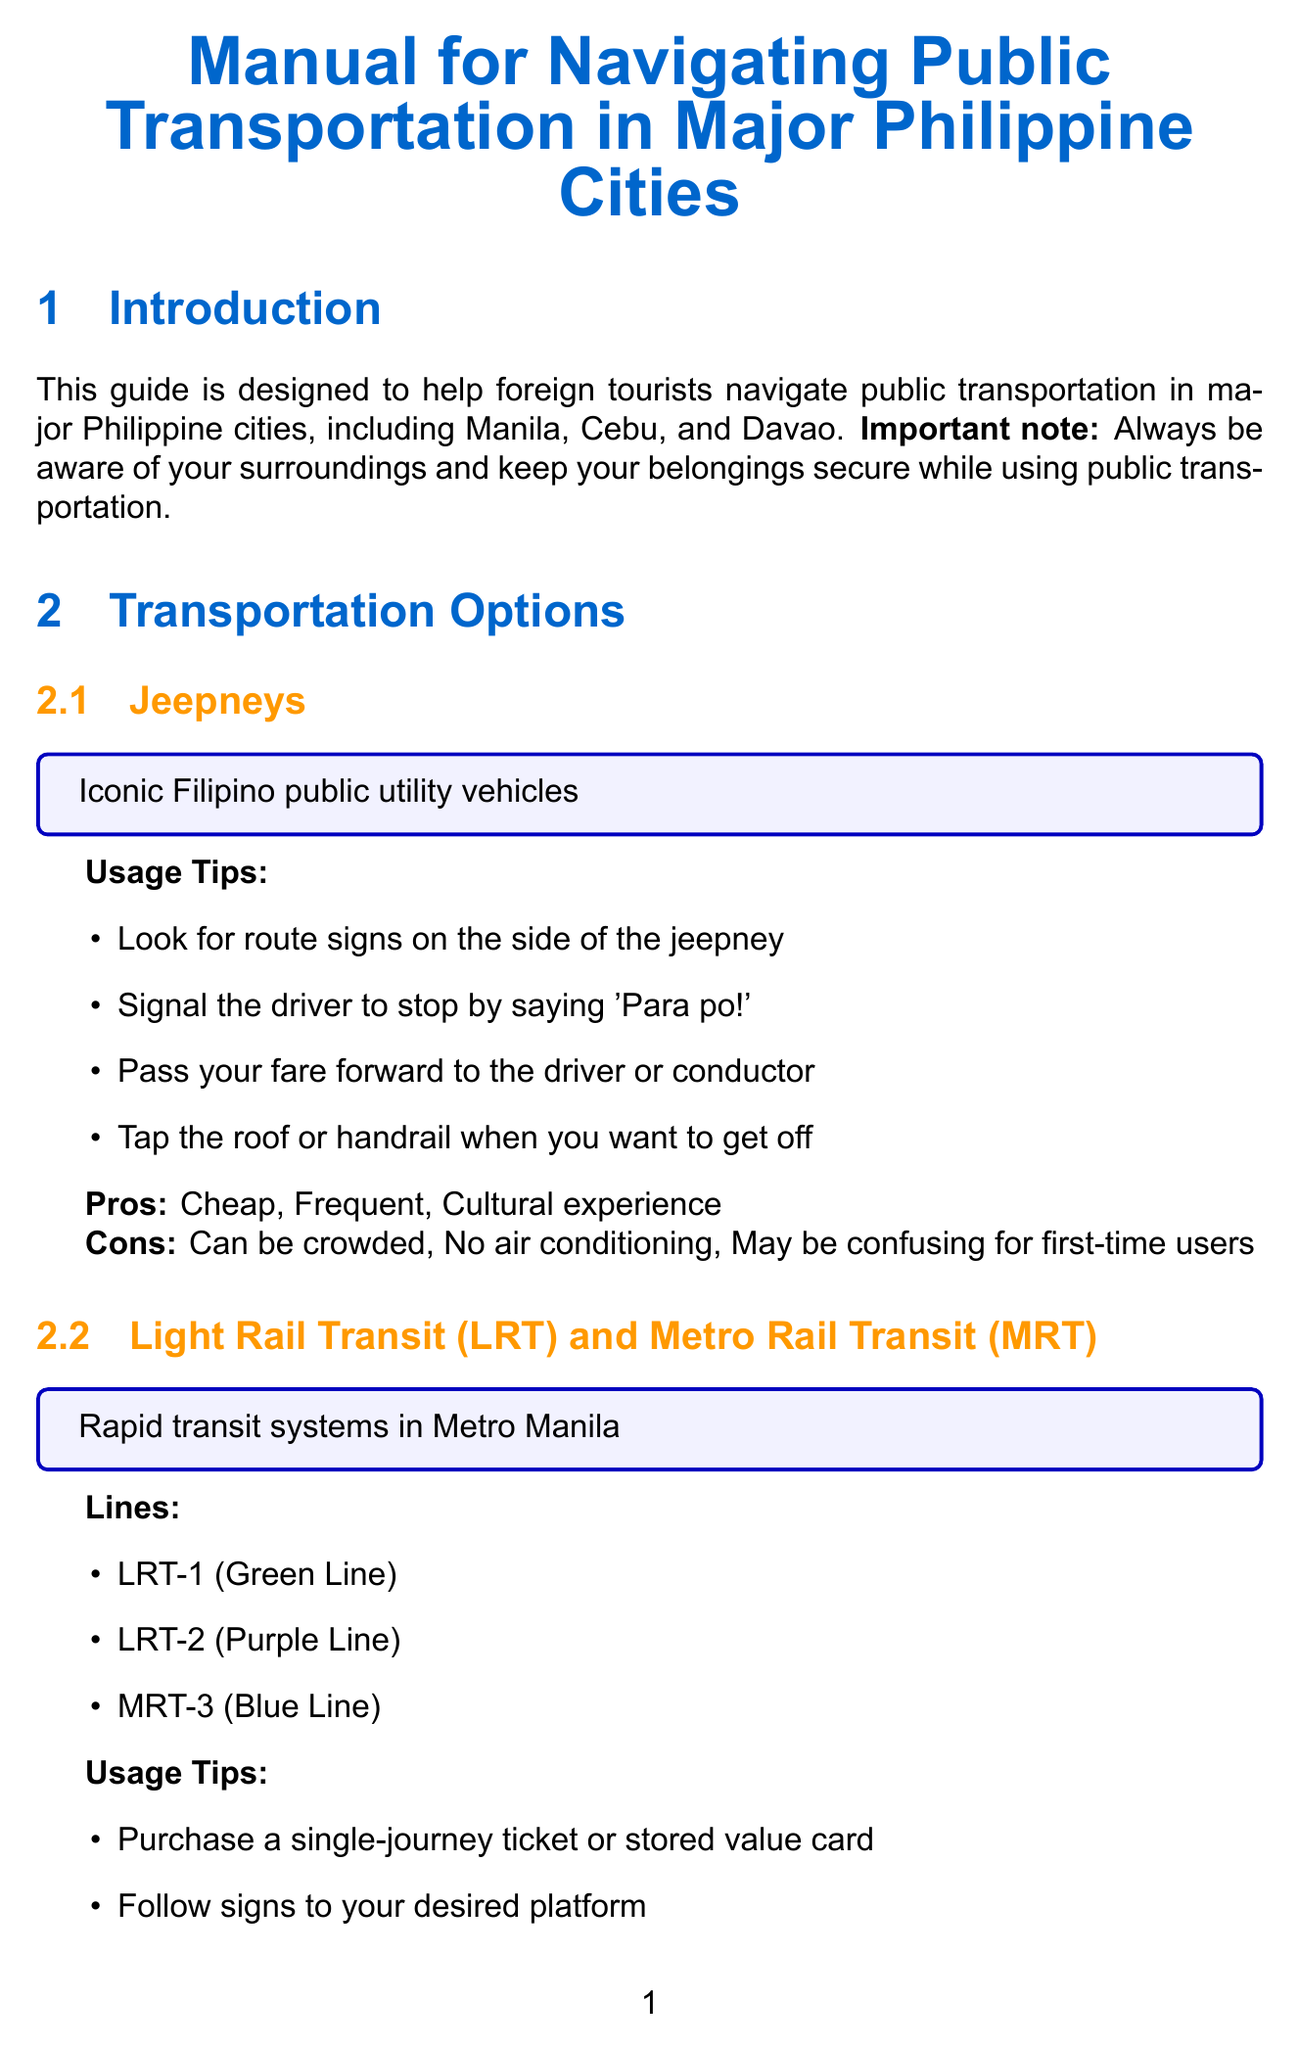What is the main purpose of this manual? The manual is designed to help foreign tourists navigate public transportation in major Philippine cities.
Answer: Help foreign tourists navigate public transportation How many rapid transit lines are mentioned? The document lists three rapid transit lines in Metro Manila.
Answer: 3 What is the unique public transportation option in Cebu? The document mentions MyBus as the unique transportation option in Cebu.
Answer: MyBus What should you do to stop a jeepney? The document states that you should say 'Para po!' to signal the driver.
Answer: Say 'Para po!' What is a safety tip related to transportation at night? The document advises to be cautious when taking public transportation at night.
Answer: Be cautious at night What is recommended for route planning in Metro Manila? The document lists Sakay.ph as a recommended app for route planning.
Answer: Sakay.ph What is the maximum capacity of taxis compared to other transportation options? The document states that taxis provide door-to-door service, which is convenient for luggage.
Answer: Door-to-door service Where is the Ninoy Aquino International Airport located? The document lists it as a main transportation hub in Manila.
Answer: Manila What is a common phrase for asking directions? The document includes "Saan po ang [destination]?" as a phrase for asking directions.
Answer: Saan po ang [destination]? 